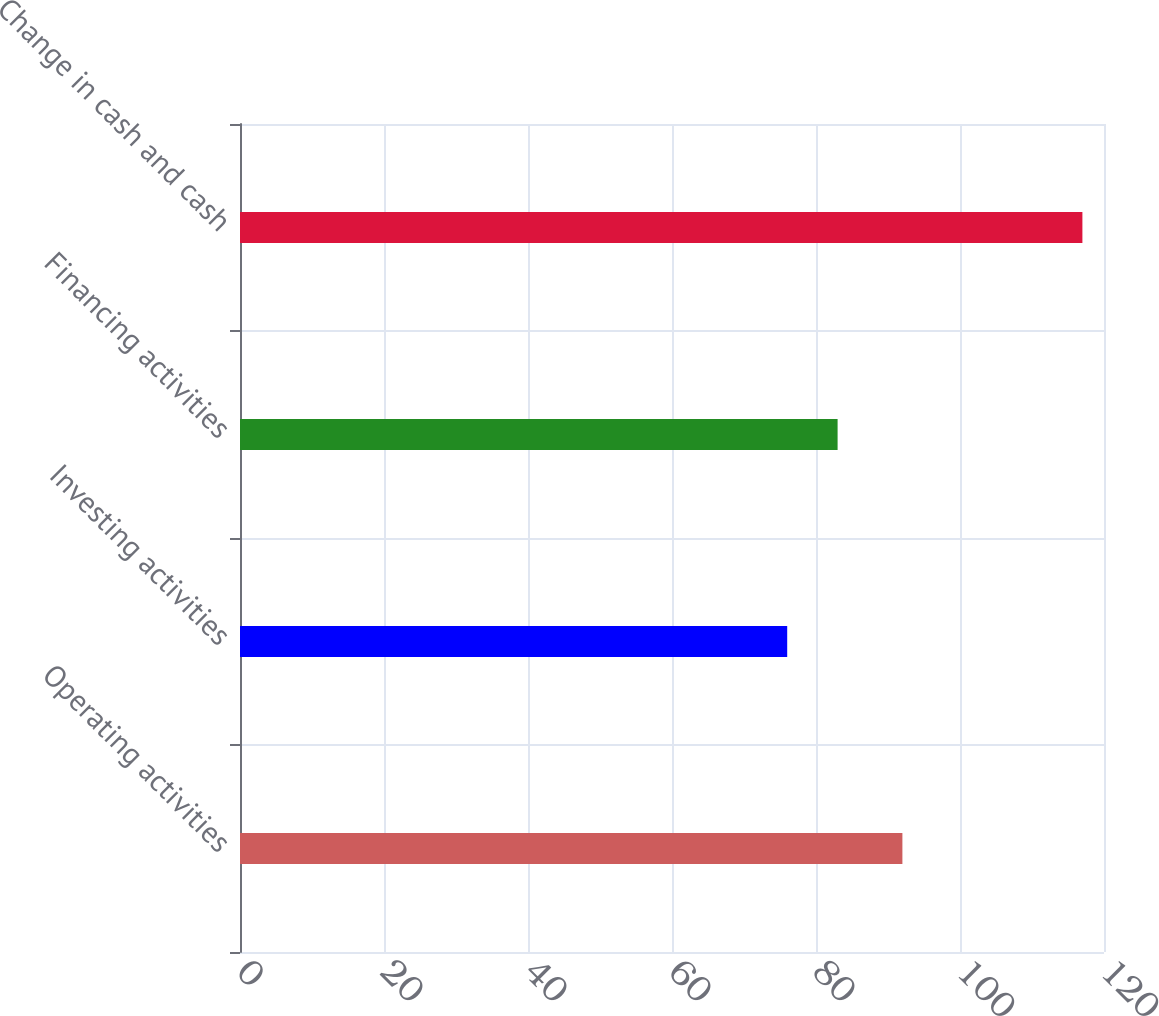Convert chart to OTSL. <chart><loc_0><loc_0><loc_500><loc_500><bar_chart><fcel>Operating activities<fcel>Investing activities<fcel>Financing activities<fcel>Change in cash and cash<nl><fcel>92<fcel>76<fcel>83<fcel>117<nl></chart> 